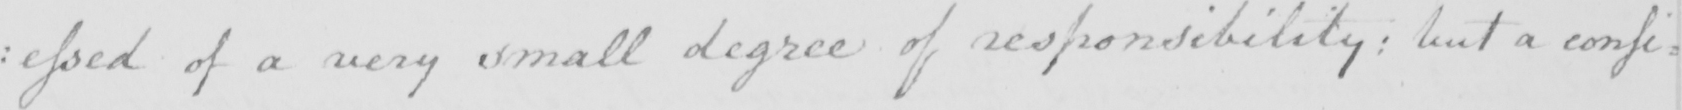What does this handwritten line say? : essed of a very small degree of responsibility :  but a consi : 